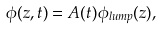<formula> <loc_0><loc_0><loc_500><loc_500>\phi ( z , t ) = A ( t ) \phi _ { l u m p } ( z ) ,</formula> 